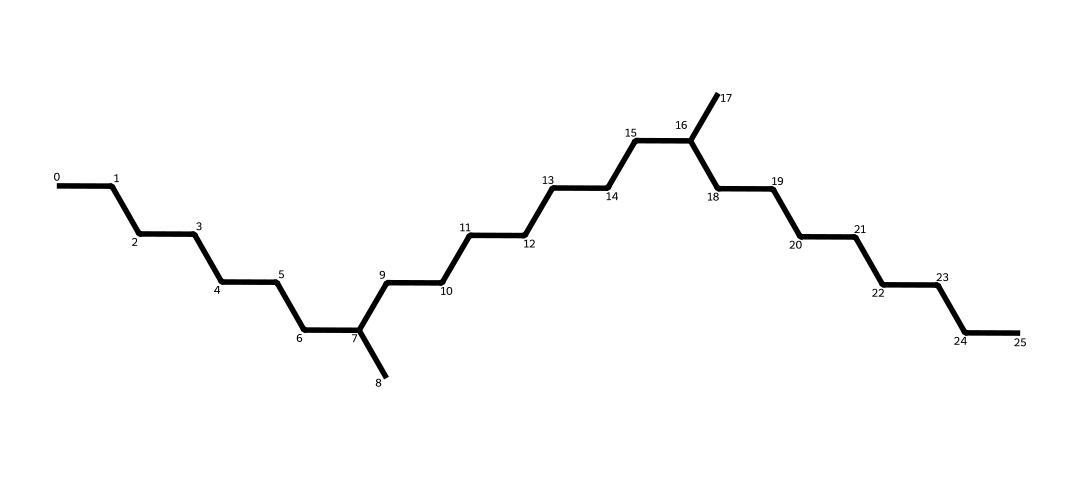What type of chemical compound is represented by this SMILES? The chemical structure corresponds to a hydrocarbon, since it consists only of carbon (C) and hydrogen (H) atoms arranged in a long chain without any functional groups.
Answer: hydrocarbon How many carbon atoms are present in this chemical? By analyzing the SMILES, we can see that there are multiple occurrences of the letter "C," indicating there are 30 carbon atoms in total.
Answer: 30 What is the main functional property of this synthetic motor oil? The structure indicates it is a lubricant, specifically designed to reduce friction and wear between moving parts in an engine due to its viscous properties.
Answer: lubricant Does this chemical contain any double bonds? The SMILES representation shows only single carbon-to-carbon bonds, indicating the absence of any double bonds in the structure.
Answer: no What is the degree of branching in this molecule? The SMILES shows branches at certain points where parentheses indicate the side chains, indicating a moderate degree of branching rather than being purely linear.
Answer: moderate How many hydrogen atoms are present based on the structure? Based on the general formula for alkanes with n carbon atoms (C_nH_(2n+2)), and with 30 carbon atoms here, the number of hydrogen atoms can be calculated as 62.
Answer: 62 